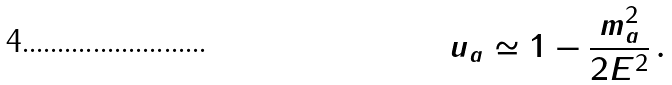Convert formula to latex. <formula><loc_0><loc_0><loc_500><loc_500>u _ { a } \simeq 1 - \frac { m _ { a } ^ { 2 } } { 2 E ^ { 2 } } \, .</formula> 